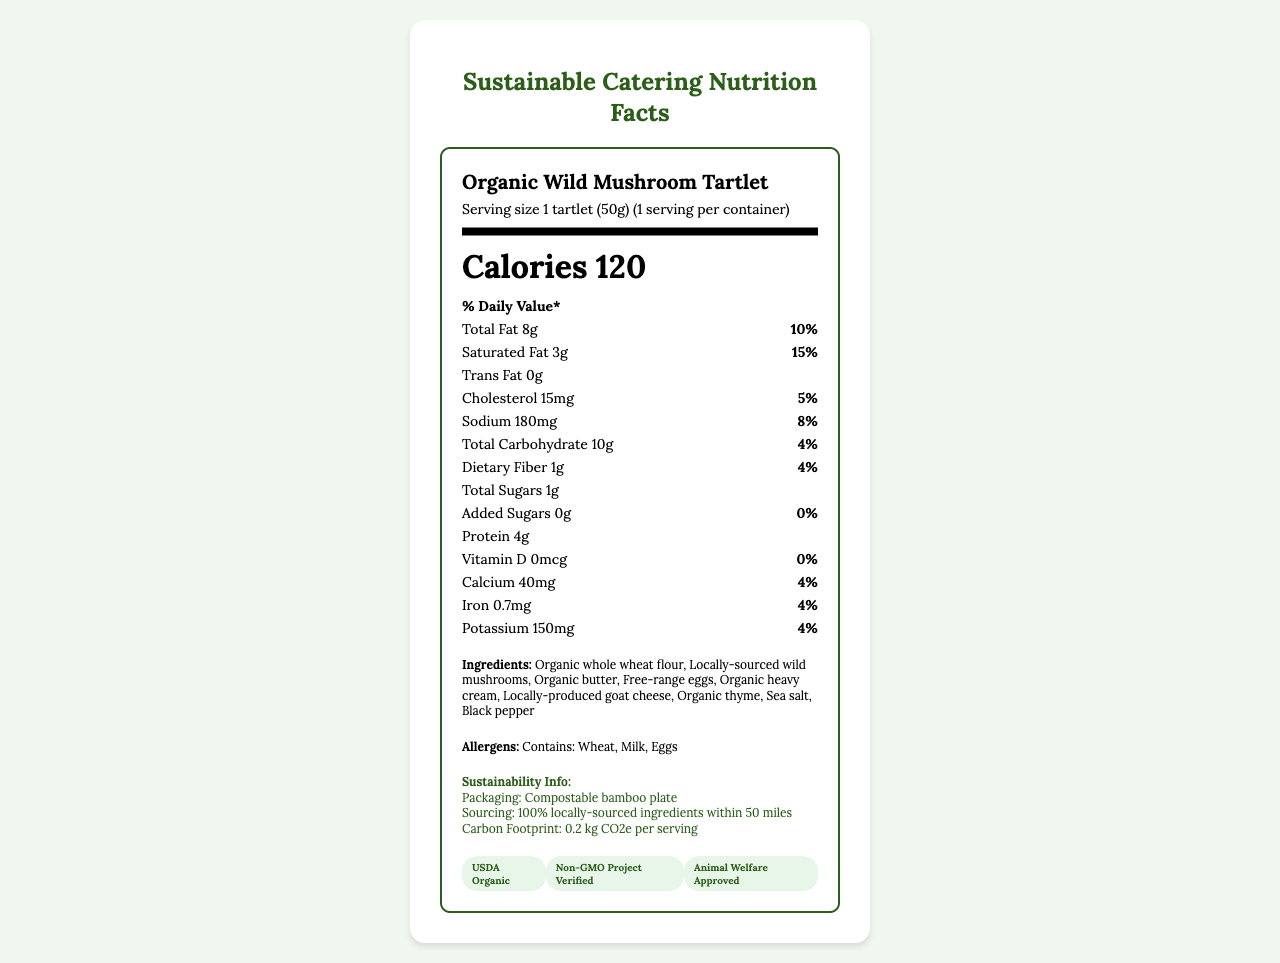what is the serving size? The serving size is listed as "1 tartlet (50g)" in the document.
Answer: 1 tartlet (50g) how many calories are in one serving? The number of calories per serving is clearly stated as 120 in the document.
Answer: 120 what is the total fat content in one tartlet? The total fat content per serving is specified as 8g.
Answer: 8g how much protein does one tartlet contain? The document indicates that one tartlet contains 4g of protein.
Answer: 4g how much sodium is in a serving of the Organic Wild Mushroom Tartlet? Sodium content is listed as 180mg per serving.
Answer: 180mg which nutrient has the highest daily value percentage? Saturated Fat has the highest daily value percentage at 15%.
Answer: Saturated Fat what is the amount of dietary fiber in each serving? Dietary fiber content is given as 1g per serving.
Answer: 1g which of these certifications does the product have? A. Gluten-Free B. USDA Organic C. Fair Trade The document lists USDA Organic as one of the certifications.
Answer: B. USDA Organic how many ingredients are in the Organic Wild Mushroom Tartlet? A. 6 B. 8 C. 9 There are 9 ingredients listed: Organic whole wheat flour, Locally-sourced wild mushrooms, Organic butter, Free-range eggs, Organic heavy cream, Locally-produced goat cheese, Organic thyme, Sea salt, Black pepper.
Answer: C. 9 is this product free of trans fat? The document states that the amount of trans fat is 0g, indicating the product is trans fat-free.
Answer: Yes describe the sustainability information provided for the Organic Wild Mushroom Tartlet. The sustainability section provides details on the packaging, sourcing, and carbon footprint for the product.
Answer: The product is packaged in a compostable bamboo plate, all ingredients are sourced within 50 miles, and the carbon footprint per serving is 0.2 kg CO2e. what is the carbon footprint per serving of this product? The document specifically mentions the carbon footprint as 0.2 kg CO2e per serving.
Answer: 0.2 kg CO2e which allergens are contained in the Organic Wild Mushroom Tartlet? The allergens listed are Wheat, Milk, and Eggs.
Answer: Wheat, Milk, Eggs what is the amount of added sugars in each serving? The document indicates that there are 0g of added sugars per serving.
Answer: 0g how much potassium is in one serving? Potassium content per serving is stated as 150mg.
Answer: 150mg does this product contain any vitamin D? The vitamin D content is listed as 0mcg, indicating that the product does not contain vitamin D.
Answer: No what is the percentage of daily value for calcium provided by one serving? The calcium daily value percentage is given as 4%.
Answer: 4% can the product's iron content be determined? The iron content is listed as 0.7mg with a daily value of 4%.
Answer: Yes how many free-range eggs are used in one serving of the Organic Wild Mushroom Tartlet? The document lists free-range eggs as an ingredient but does not specify the amount used per serving.
Answer: Not enough information 